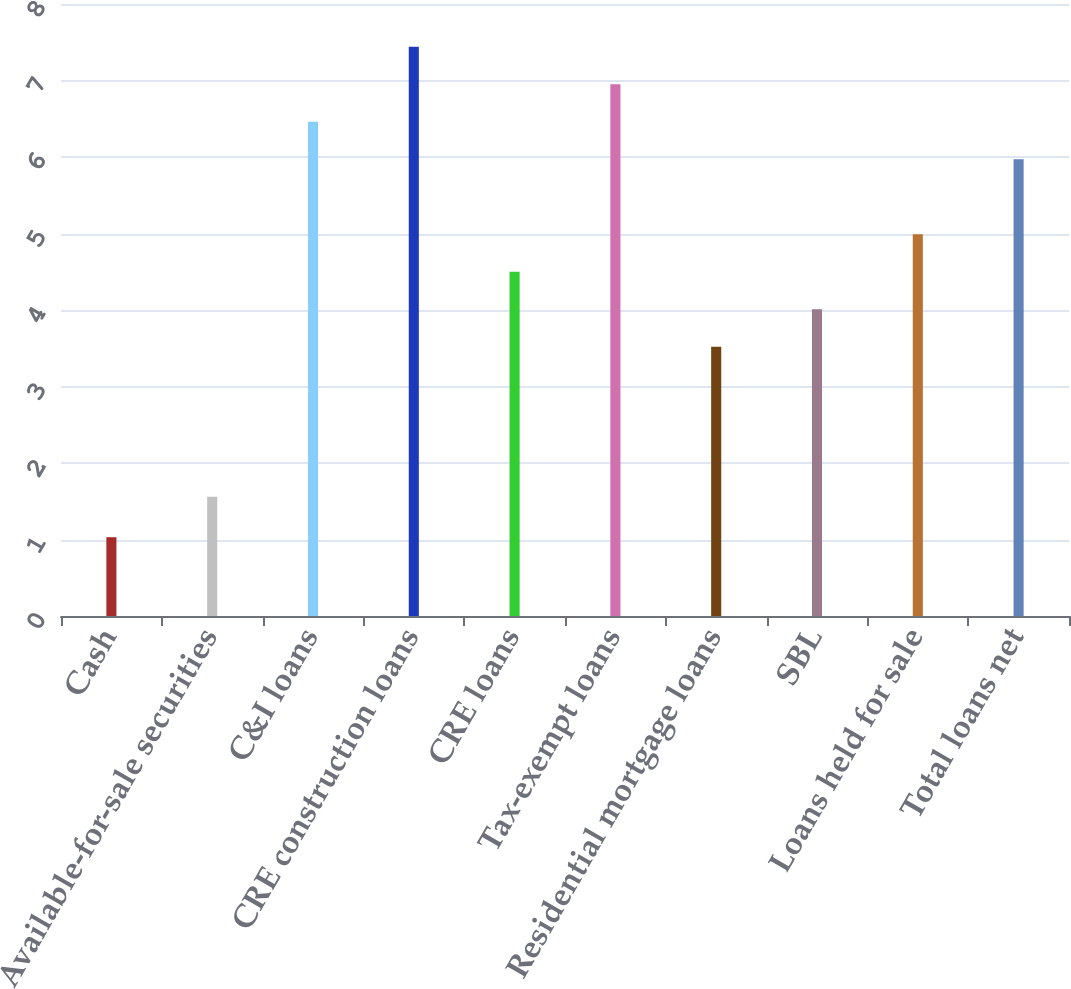Convert chart to OTSL. <chart><loc_0><loc_0><loc_500><loc_500><bar_chart><fcel>Cash<fcel>Available-for-sale securities<fcel>C&I loans<fcel>CRE construction loans<fcel>CRE loans<fcel>Tax-exempt loans<fcel>Residential mortgage loans<fcel>SBL<fcel>Loans held for sale<fcel>Total loans net<nl><fcel>1.03<fcel>1.56<fcel>6.46<fcel>7.44<fcel>4.5<fcel>6.95<fcel>3.52<fcel>4.01<fcel>4.99<fcel>5.97<nl></chart> 